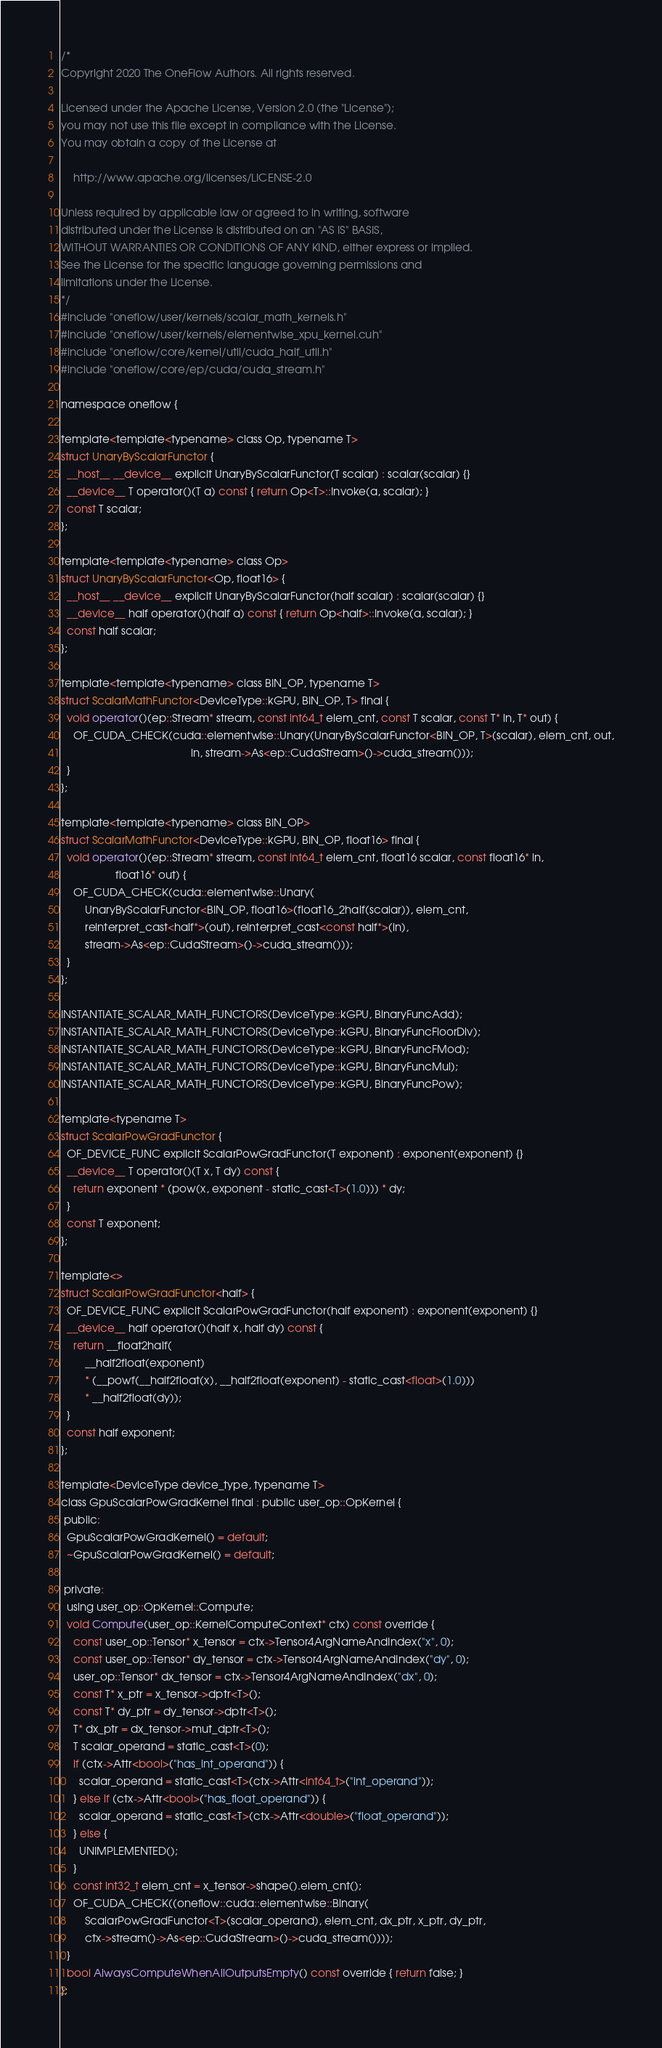Convert code to text. <code><loc_0><loc_0><loc_500><loc_500><_Cuda_>/*
Copyright 2020 The OneFlow Authors. All rights reserved.

Licensed under the Apache License, Version 2.0 (the "License");
you may not use this file except in compliance with the License.
You may obtain a copy of the License at

    http://www.apache.org/licenses/LICENSE-2.0

Unless required by applicable law or agreed to in writing, software
distributed under the License is distributed on an "AS IS" BASIS,
WITHOUT WARRANTIES OR CONDITIONS OF ANY KIND, either express or implied.
See the License for the specific language governing permissions and
limitations under the License.
*/
#include "oneflow/user/kernels/scalar_math_kernels.h"
#include "oneflow/user/kernels/elementwise_xpu_kernel.cuh"
#include "oneflow/core/kernel/util/cuda_half_util.h"
#include "oneflow/core/ep/cuda/cuda_stream.h"

namespace oneflow {

template<template<typename> class Op, typename T>
struct UnaryByScalarFunctor {
  __host__ __device__ explicit UnaryByScalarFunctor(T scalar) : scalar(scalar) {}
  __device__ T operator()(T a) const { return Op<T>::Invoke(a, scalar); }
  const T scalar;
};

template<template<typename> class Op>
struct UnaryByScalarFunctor<Op, float16> {
  __host__ __device__ explicit UnaryByScalarFunctor(half scalar) : scalar(scalar) {}
  __device__ half operator()(half a) const { return Op<half>::Invoke(a, scalar); }
  const half scalar;
};

template<template<typename> class BIN_OP, typename T>
struct ScalarMathFunctor<DeviceType::kGPU, BIN_OP, T> final {
  void operator()(ep::Stream* stream, const int64_t elem_cnt, const T scalar, const T* in, T* out) {
    OF_CUDA_CHECK(cuda::elementwise::Unary(UnaryByScalarFunctor<BIN_OP, T>(scalar), elem_cnt, out,
                                           in, stream->As<ep::CudaStream>()->cuda_stream()));
  }
};

template<template<typename> class BIN_OP>
struct ScalarMathFunctor<DeviceType::kGPU, BIN_OP, float16> final {
  void operator()(ep::Stream* stream, const int64_t elem_cnt, float16 scalar, const float16* in,
                  float16* out) {
    OF_CUDA_CHECK(cuda::elementwise::Unary(
        UnaryByScalarFunctor<BIN_OP, float16>(float16_2half(scalar)), elem_cnt,
        reinterpret_cast<half*>(out), reinterpret_cast<const half*>(in),
        stream->As<ep::CudaStream>()->cuda_stream()));
  }
};

INSTANTIATE_SCALAR_MATH_FUNCTORS(DeviceType::kGPU, BinaryFuncAdd);
INSTANTIATE_SCALAR_MATH_FUNCTORS(DeviceType::kGPU, BinaryFuncFloorDiv);
INSTANTIATE_SCALAR_MATH_FUNCTORS(DeviceType::kGPU, BinaryFuncFMod);
INSTANTIATE_SCALAR_MATH_FUNCTORS(DeviceType::kGPU, BinaryFuncMul);
INSTANTIATE_SCALAR_MATH_FUNCTORS(DeviceType::kGPU, BinaryFuncPow);

template<typename T>
struct ScalarPowGradFunctor {
  OF_DEVICE_FUNC explicit ScalarPowGradFunctor(T exponent) : exponent(exponent) {}
  __device__ T operator()(T x, T dy) const {
    return exponent * (pow(x, exponent - static_cast<T>(1.0))) * dy;
  }
  const T exponent;
};

template<>
struct ScalarPowGradFunctor<half> {
  OF_DEVICE_FUNC explicit ScalarPowGradFunctor(half exponent) : exponent(exponent) {}
  __device__ half operator()(half x, half dy) const {
    return __float2half(
        __half2float(exponent)
        * (__powf(__half2float(x), __half2float(exponent) - static_cast<float>(1.0)))
        * __half2float(dy));
  }
  const half exponent;
};

template<DeviceType device_type, typename T>
class GpuScalarPowGradKernel final : public user_op::OpKernel {
 public:
  GpuScalarPowGradKernel() = default;
  ~GpuScalarPowGradKernel() = default;

 private:
  using user_op::OpKernel::Compute;
  void Compute(user_op::KernelComputeContext* ctx) const override {
    const user_op::Tensor* x_tensor = ctx->Tensor4ArgNameAndIndex("x", 0);
    const user_op::Tensor* dy_tensor = ctx->Tensor4ArgNameAndIndex("dy", 0);
    user_op::Tensor* dx_tensor = ctx->Tensor4ArgNameAndIndex("dx", 0);
    const T* x_ptr = x_tensor->dptr<T>();
    const T* dy_ptr = dy_tensor->dptr<T>();
    T* dx_ptr = dx_tensor->mut_dptr<T>();
    T scalar_operand = static_cast<T>(0);
    if (ctx->Attr<bool>("has_int_operand")) {
      scalar_operand = static_cast<T>(ctx->Attr<int64_t>("int_operand"));
    } else if (ctx->Attr<bool>("has_float_operand")) {
      scalar_operand = static_cast<T>(ctx->Attr<double>("float_operand"));
    } else {
      UNIMPLEMENTED();
    }
    const int32_t elem_cnt = x_tensor->shape().elem_cnt();
    OF_CUDA_CHECK((oneflow::cuda::elementwise::Binary(
        ScalarPowGradFunctor<T>(scalar_operand), elem_cnt, dx_ptr, x_ptr, dy_ptr,
        ctx->stream()->As<ep::CudaStream>()->cuda_stream())));
  }
  bool AlwaysComputeWhenAllOutputsEmpty() const override { return false; }
};
</code> 